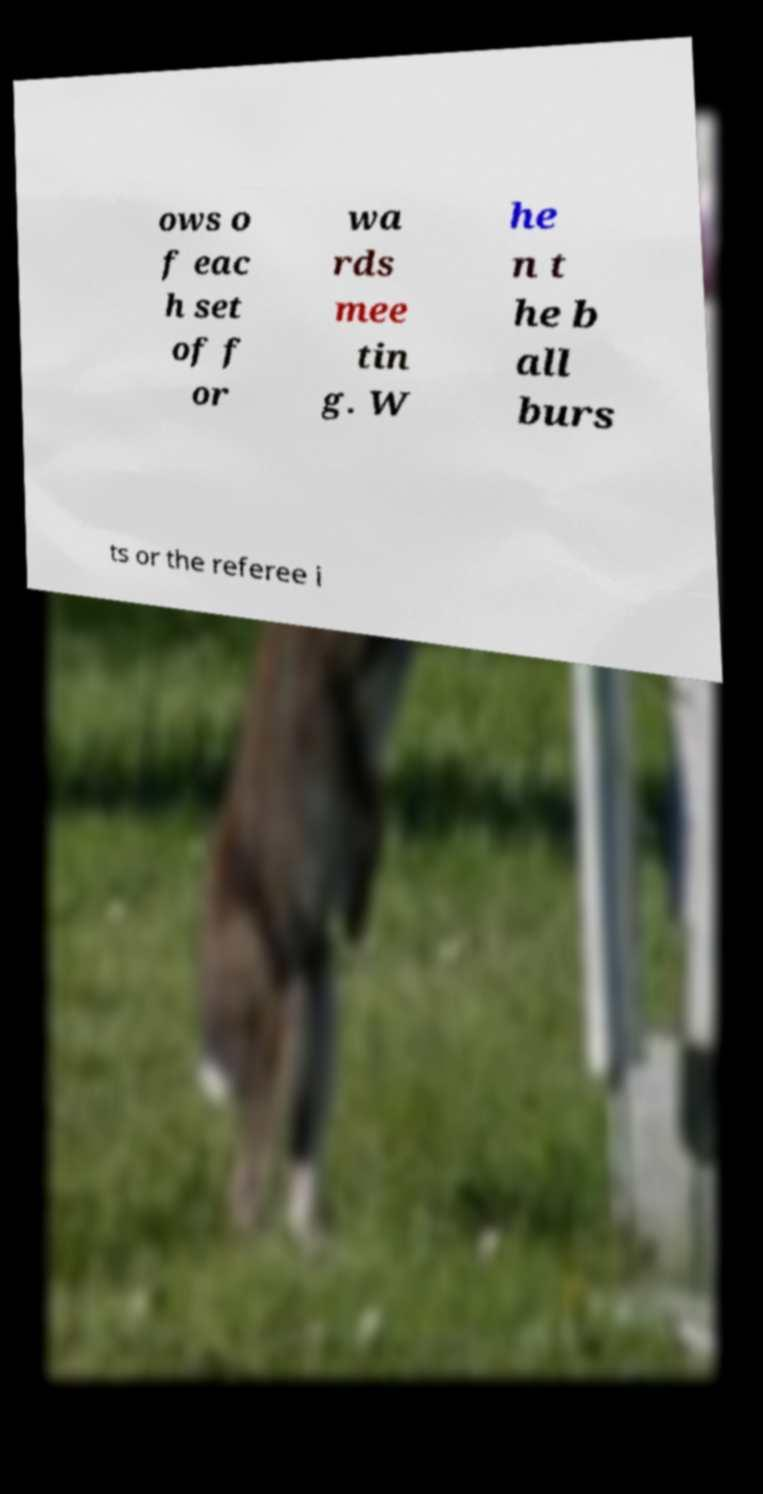Could you assist in decoding the text presented in this image and type it out clearly? ows o f eac h set of f or wa rds mee tin g. W he n t he b all burs ts or the referee i 